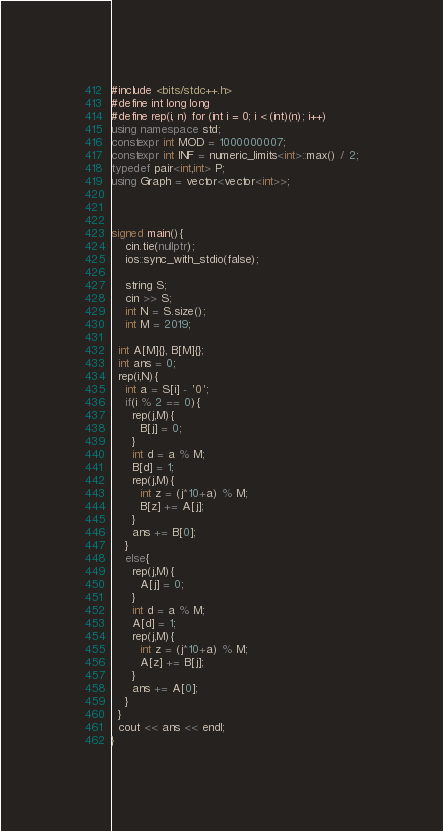<code> <loc_0><loc_0><loc_500><loc_500><_C++_>#include <bits/stdc++.h>
#define int long long
#define rep(i, n) for (int i = 0; i < (int)(n); i++)
using namespace std;
constexpr int MOD = 1000000007;
constexpr int INF = numeric_limits<int>::max() / 2;
typedef pair<int,int> P;
using Graph = vector<vector<int>>;
 
 
 
signed main(){
	cin.tie(nullptr);
	ios::sync_with_stdio(false);
 
    string S;
    cin >> S;
    int N = S.size();
    int M = 2019;
 
  int A[M]{}, B[M]{};
  int ans = 0;
  rep(i,N){
    int a = S[i] - '0';
    if(i % 2 == 0){
      rep(j,M){
        B[j] = 0;
      }
      int d = a % M;
      B[d] = 1;
      rep(j,M){
        int z = (j*10+a) % M;
        B[z] += A[j];
      }
      ans += B[0];
    }
    else{
      rep(j,M){
        A[j] = 0;
      }
      int d = a % M;
      A[d] = 1;
      rep(j,M){
        int z = (j*10+a) % M;
        A[z] += B[j];
      }
      ans += A[0];
    }
  }
  cout << ans << endl;
}</code> 